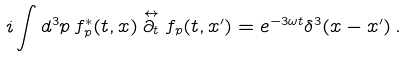Convert formula to latex. <formula><loc_0><loc_0><loc_500><loc_500>i \int d ^ { 3 } p \, f ^ { * } _ { p } ( t , { x } ) \stackrel { \leftrightarrow } { \partial _ { t } } f _ { p } ( t , { x } ^ { \prime } ) = e ^ { - 3 \omega t } \delta ^ { 3 } ( { x } - { x } ^ { \prime } ) \, .</formula> 